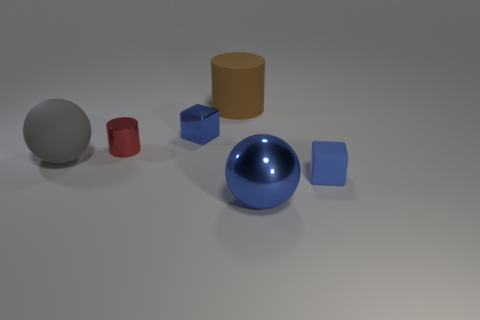How big is the cylinder that is in front of the large brown thing?
Give a very brief answer. Small. What number of other things are there of the same material as the large brown cylinder
Your response must be concise. 2. Are there any tiny blue metal cubes that are in front of the blue cube that is on the right side of the shiny ball?
Offer a terse response. No. Are there any other things that have the same shape as the large gray thing?
Provide a short and direct response. Yes. The tiny shiny thing that is the same shape as the brown matte object is what color?
Offer a very short reply. Red. The red shiny cylinder is what size?
Your answer should be compact. Small. Is the number of large brown objects left of the tiny shiny block less than the number of gray matte spheres?
Make the answer very short. Yes. Are the brown object and the cube that is in front of the small cylinder made of the same material?
Provide a short and direct response. Yes. There is a matte object that is in front of the sphere that is left of the small metal cylinder; is there a blue shiny sphere behind it?
Make the answer very short. No. Is there any other thing that is the same size as the red metal thing?
Your response must be concise. Yes. 